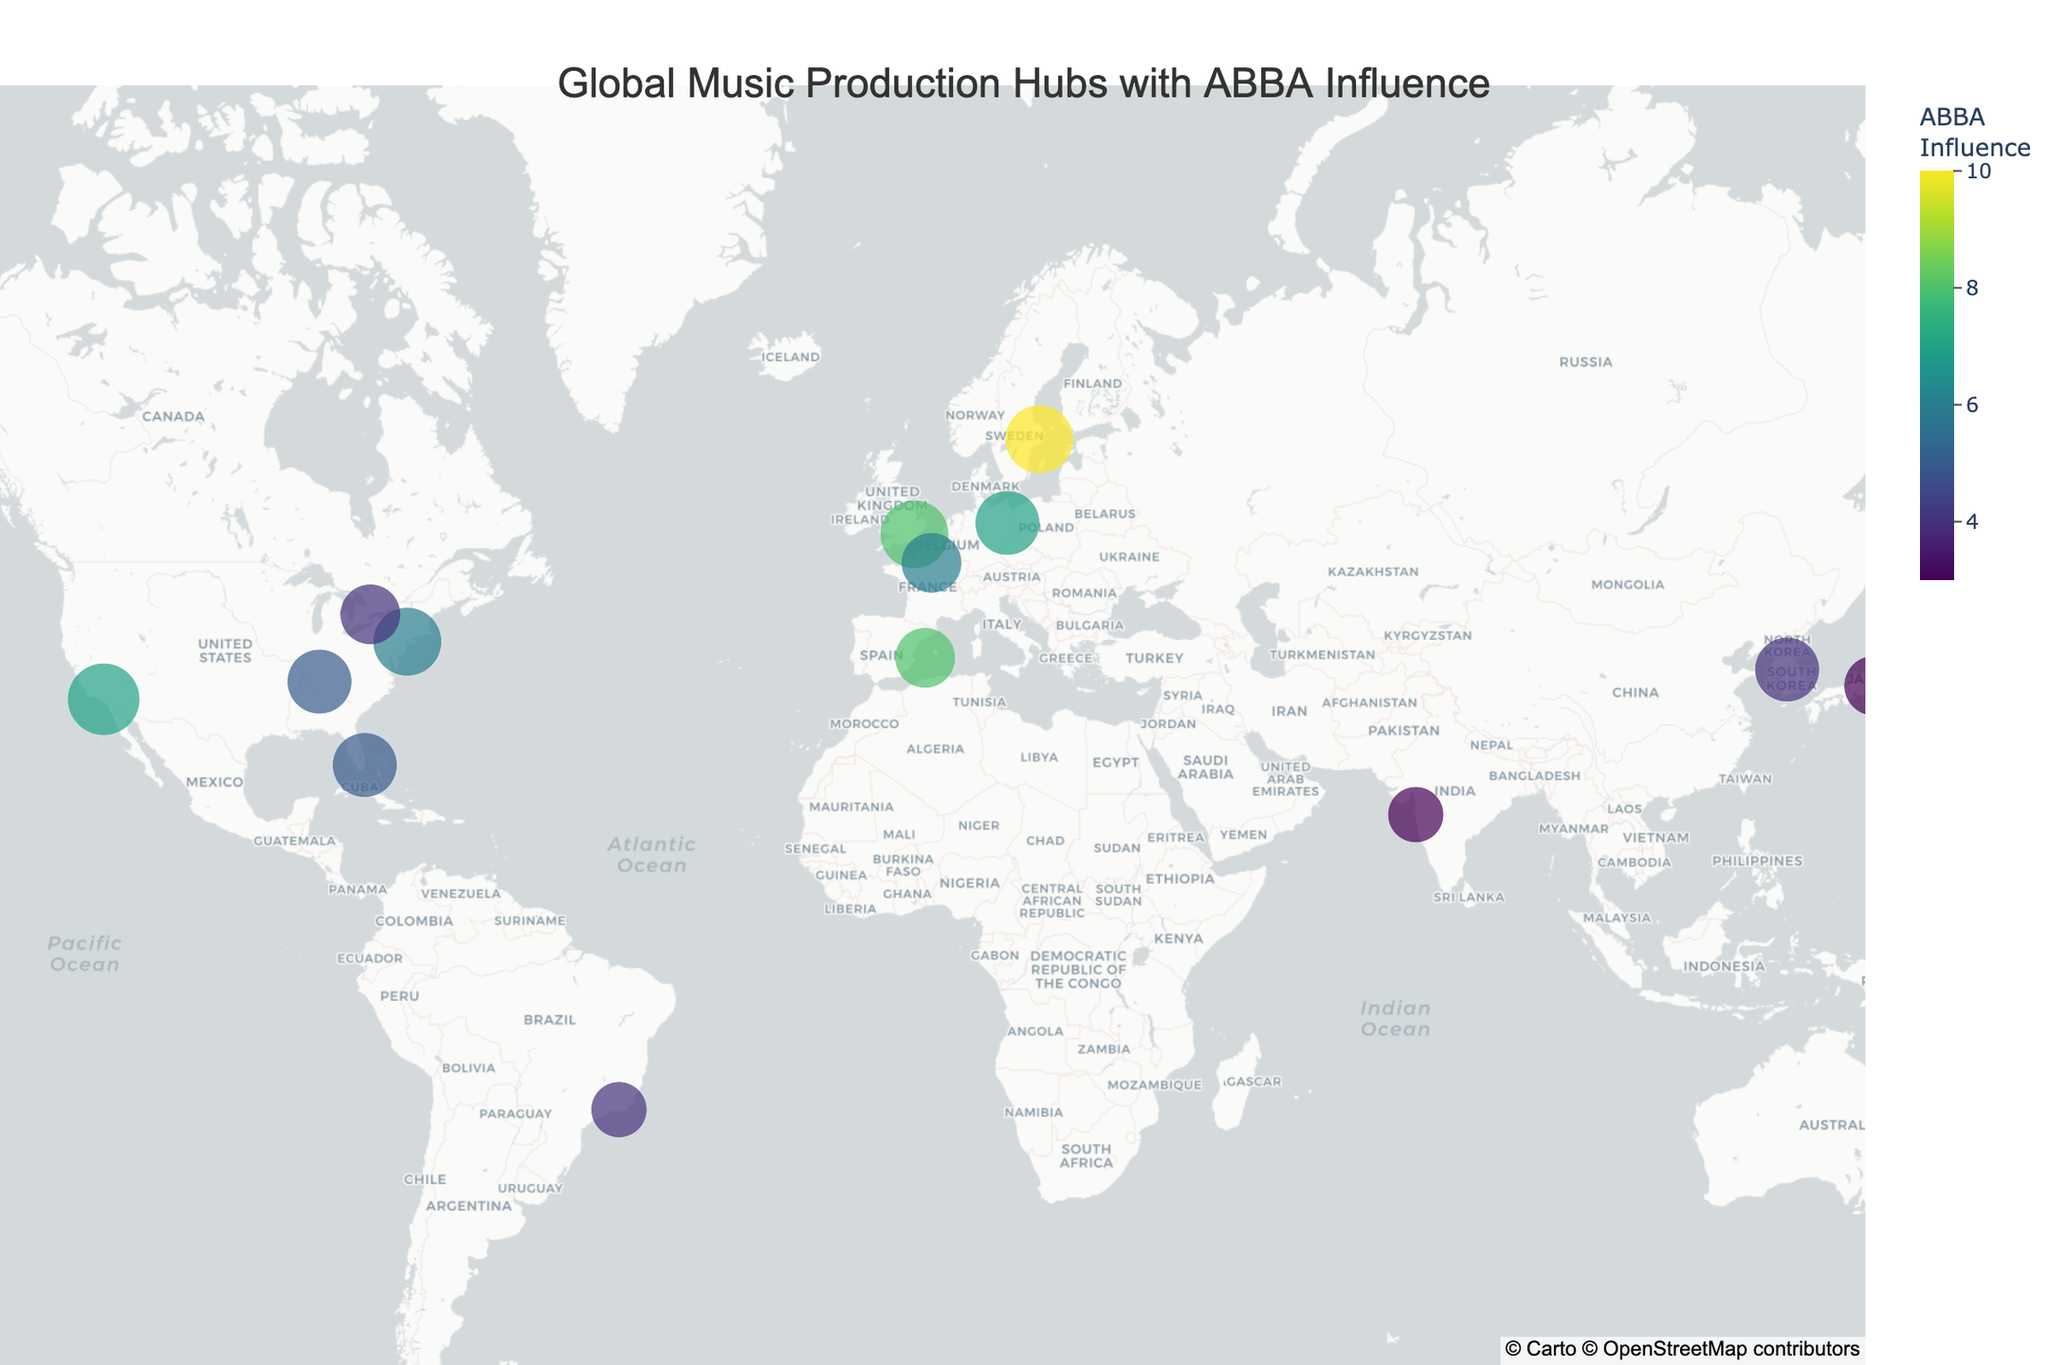How many cities have an ABBA Influence score of 7 or higher? In the plot, we need to count the data points where the ABBA Influence score is 7 or greater. The cities with these scores are Stockholm, Los Angeles, New York City, London, Berlin, and Ibiza.
Answer: 6 Which city has the highest Importance score and what is its ABBA Influence score? From the figure, Los Angeles stands out as it has the largest marker indicating the highest Importance score of 10. The ABBA Influence score for Los Angeles is 7.
Answer: Los Angeles, 7 How does the ABBA Influence score for Tokyo compare to that of New York City? The plot shows the ABBA Influence score for Tokyo as 3 and for New York City as 6. Therefore, New York City has a higher ABBA Influence score compared to Tokyo.
Answer: New York City has a higher ABBA Influence score than Tokyo What is the combined Importance score of the cities in the USA? The cities in the USA on the plot are Los Angeles (10), New York City (9), Nashville (8), and Miami (8). Adding these scores gives 10 + 9 + 8 + 8 = 35.
Answer: 35 Which city in Europe has the lowest Importance score? Looking at the European cities on the map, Paris and Berlin have Importance scores of 7 and 8 respectively, but Stockholm has a lower score of 9. Therefore, the city in Europe with the lowest Importance score would be Paris.
Answer: Paris What is the average ABBA Influence score of the global music production hubs? Sum the ABBA Influence scores: 10 (Stockholm) + 7 (Los Angeles) + 6 (New York City) + 8 (London) + 5 (Nashville) + 4 (Seoul) + 3 (Tokyo) + 7 (Berlin) + 6 (Paris) + 5 (Miami) + 4 (Toronto) + 5 (Melbourne) + 3 (Mumbai) + 4 (Rio de Janeiro) + 8 (Ibiza) = 85. There are 15 cities, so the average is 85 / 15 = 5.67.
Answer: 5.67 Which city has the highest ABBA Influence score outside of Europe? The city outside of Europe with the highest ABBA Influence score on the plot is Los Angeles, with a score of 7.
Answer: Los Angeles How many cities have both an Importance and ABBA Influence score of 8 or higher? We need to count the cities where both Importance and ABBA Influence scores are at least 8. Stockholm (Importance 9, ABBA 10), Los Angeles (Importance 10, ABBA 7) do not meet both criteria. London, Berlin, and Ibiza meet these criteria. Hence, we have 3 cities.
Answer: 3 cities What is the total number of cities displayed on the figure? We count each data point to determine the number of cities. Based on the plot, there are 15 cities in total.
Answer: 15 